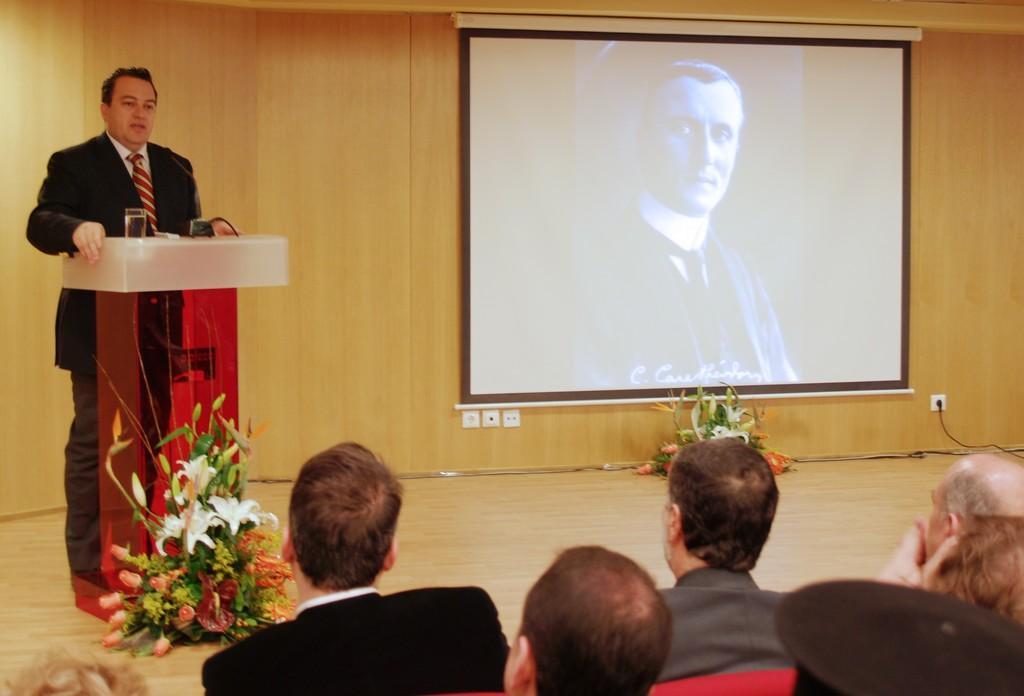How would you summarize this image in a sentence or two? In this image there are group of people sitting, there are flower bouquets , screen, a person standing near a podium. 